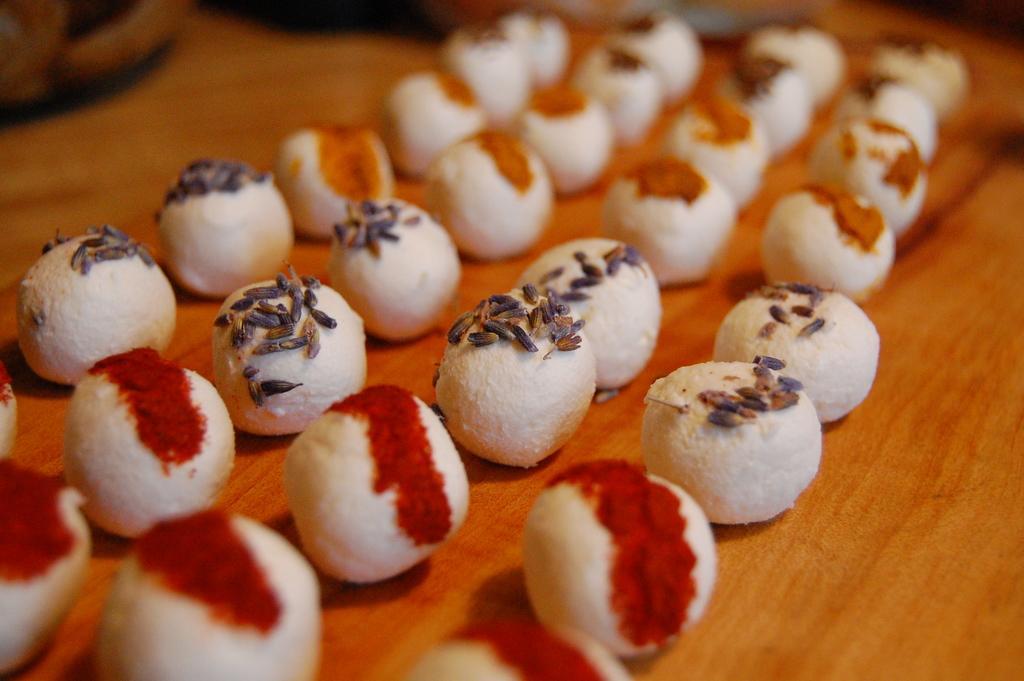Describe this image in one or two sentences. In this image we can see some food containing cumin seeds on it placed on the table. 